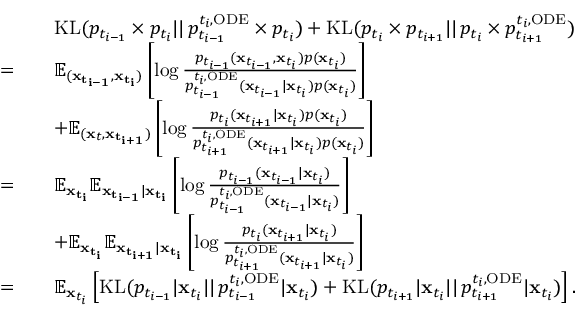<formula> <loc_0><loc_0><loc_500><loc_500>\begin{array} { r l } & { \quad K L ( p _ { t _ { i - 1 } } \times p _ { t _ { i } } | | \, p _ { t _ { i - 1 } } ^ { t _ { i } , O D E } \times p _ { t _ { i } } ) + K L ( p _ { t _ { i } } \times p _ { t _ { i + 1 } } | | \, p _ { t _ { i } } \times p _ { t _ { i + 1 } } ^ { t _ { i } , O D E } ) } \\ { = } & { \quad \mathbb { E } _ { ( x _ { t _ { i - 1 } } , x _ { t _ { i } } ) } \left [ \log \frac { p _ { t _ { i - 1 } } ( x _ { t _ { i - 1 } } , x _ { t _ { i } } ) p ( x _ { t _ { i } } ) } { p _ { t _ { i - 1 } } ^ { t _ { i } , O D E } ( x _ { t _ { i - 1 } } | x _ { t _ { i } } ) p ( x _ { t _ { i } } ) } \right ] } \\ & { \quad + \mathbb { E } _ { ( x _ { t } , x _ { t _ { i + 1 } } ) } \left [ \log \frac { p _ { t _ { i } } ( x _ { t _ { i + 1 } } | x _ { t _ { i } } ) p ( x _ { t _ { i } } ) } { p _ { t _ { i + 1 } } ^ { t _ { i } , O D E } ( x _ { t _ { i + 1 } } | x _ { t _ { i } } ) p ( x _ { t _ { i } } ) } \right ] } \\ { = } & { \quad \mathbb { E } _ { x _ { t _ { i } } } \mathbb { E } _ { x _ { t _ { i - 1 } } | x _ { t _ { i } } } \left [ \log \frac { p _ { t _ { i - 1 } } ( x _ { t _ { i - 1 } } | x _ { t _ { i } } ) } { p _ { t _ { i - 1 } } ^ { t _ { i } , O D E } ( x _ { t _ { i - 1 } } | x _ { t _ { i } } ) } \right ] } \\ & { \quad + \mathbb { E } _ { x _ { t _ { i } } } \mathbb { E } _ { x _ { t _ { i + 1 } } | x _ { t _ { i } } } \left [ \log \frac { p _ { t _ { i } } ( x _ { t _ { i + 1 } } | x _ { t _ { i } } ) } { p _ { t _ { i + 1 } } ^ { t _ { i } , O D E } ( x _ { t _ { i + 1 } } | x _ { t _ { i } } ) } \right ] } \\ { = } & { \quad \mathbb { E } _ { x _ { t _ { i } } } \left [ K L ( p _ { t _ { i - 1 } } | x _ { t _ { i } } | | \, p _ { t _ { i - 1 } } ^ { t _ { i } , O D E } | x _ { t _ { i } } ) + K L ( p _ { t _ { i + 1 } } | x _ { t _ { i } } | | \, p _ { t _ { i + 1 } } ^ { t _ { i } , O D E } | x _ { t _ { i } } ) \right ] . } \end{array}</formula> 